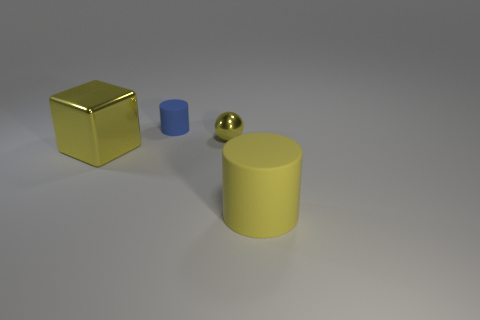Is there a tiny shiny object?
Make the answer very short. Yes. How many cylinders are the same color as the large cube?
Keep it short and to the point. 1. Does the big yellow block have the same material as the cylinder that is behind the big shiny object?
Your answer should be compact. No. Is the number of metal cubes that are left of the big yellow cube greater than the number of tiny balls?
Give a very brief answer. No. Is there anything else that has the same size as the metallic sphere?
Make the answer very short. Yes. There is a big cylinder; is it the same color as the metallic thing that is to the left of the small metallic thing?
Provide a succinct answer. Yes. Are there the same number of tiny metal objects that are to the right of the small yellow object and rubber cylinders that are right of the small cylinder?
Give a very brief answer. No. There is a big yellow thing that is to the left of the yellow matte cylinder; what is its material?
Provide a short and direct response. Metal. What number of objects are either big yellow objects left of the small rubber cylinder or yellow objects?
Ensure brevity in your answer.  3. How many other objects are there of the same shape as the big shiny thing?
Your response must be concise. 0. 